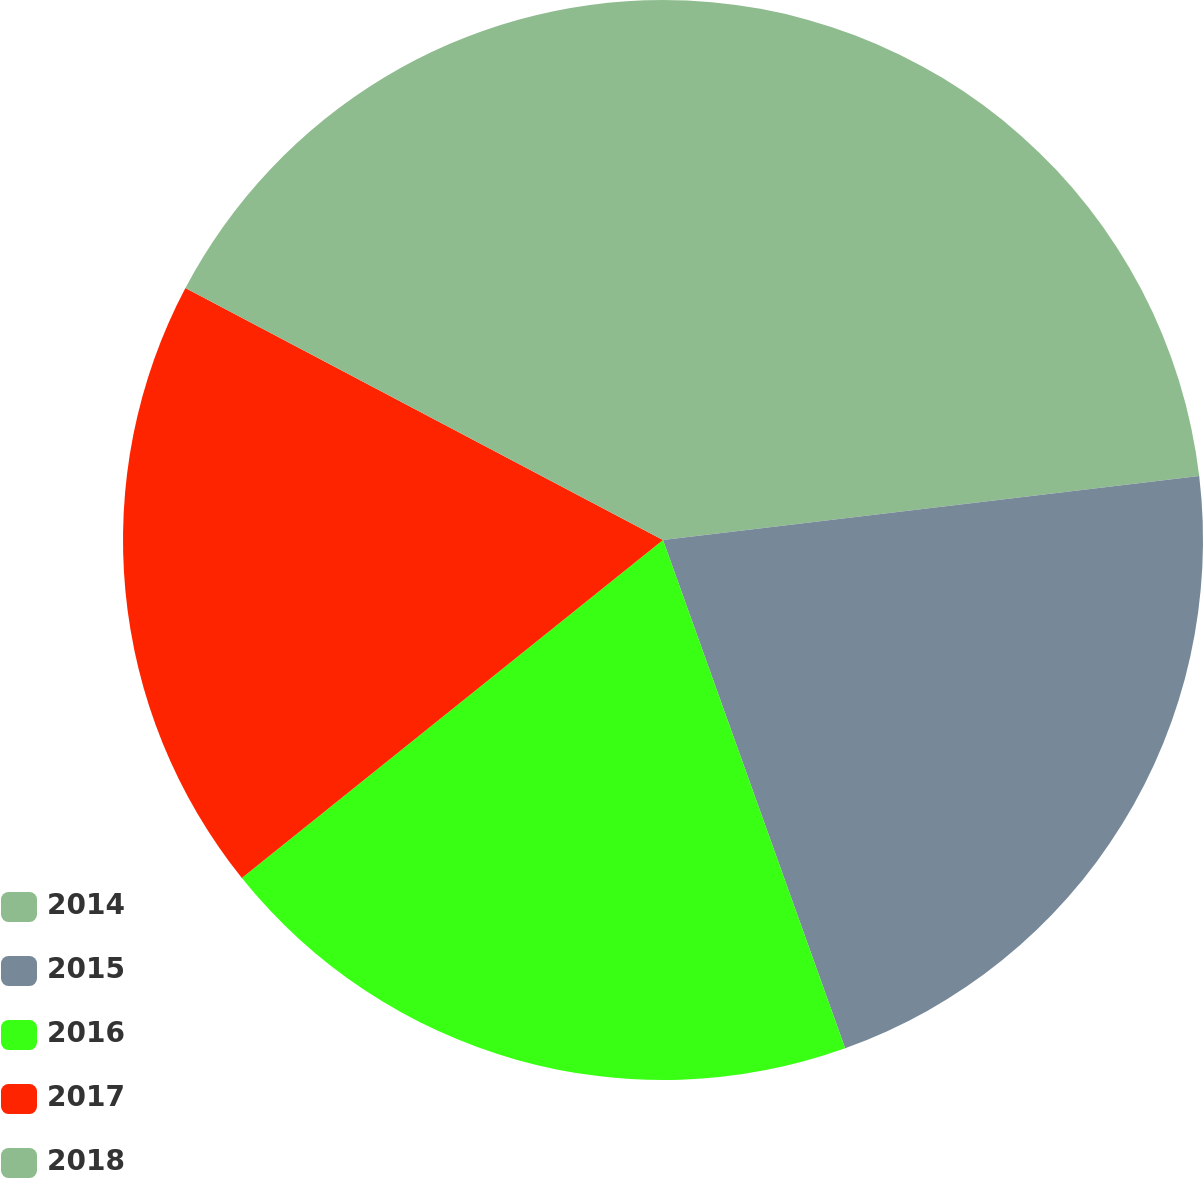<chart> <loc_0><loc_0><loc_500><loc_500><pie_chart><fcel>2014<fcel>2015<fcel>2016<fcel>2017<fcel>2018<nl><fcel>23.11%<fcel>21.41%<fcel>19.71%<fcel>18.49%<fcel>17.27%<nl></chart> 